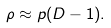<formula> <loc_0><loc_0><loc_500><loc_500>\rho \approx p ( D - 1 ) .</formula> 